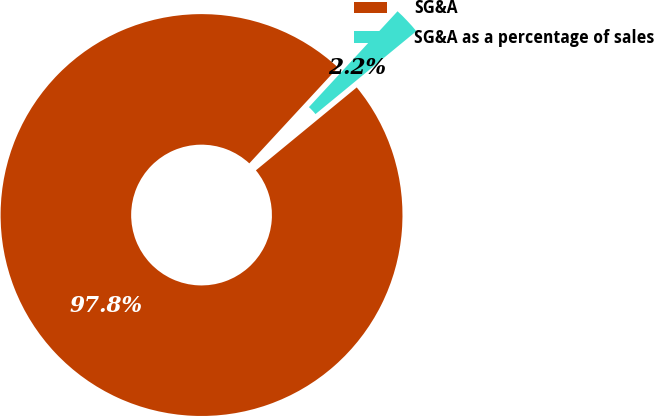<chart> <loc_0><loc_0><loc_500><loc_500><pie_chart><fcel>SG&A<fcel>SG&A as a percentage of sales<nl><fcel>97.83%<fcel>2.17%<nl></chart> 